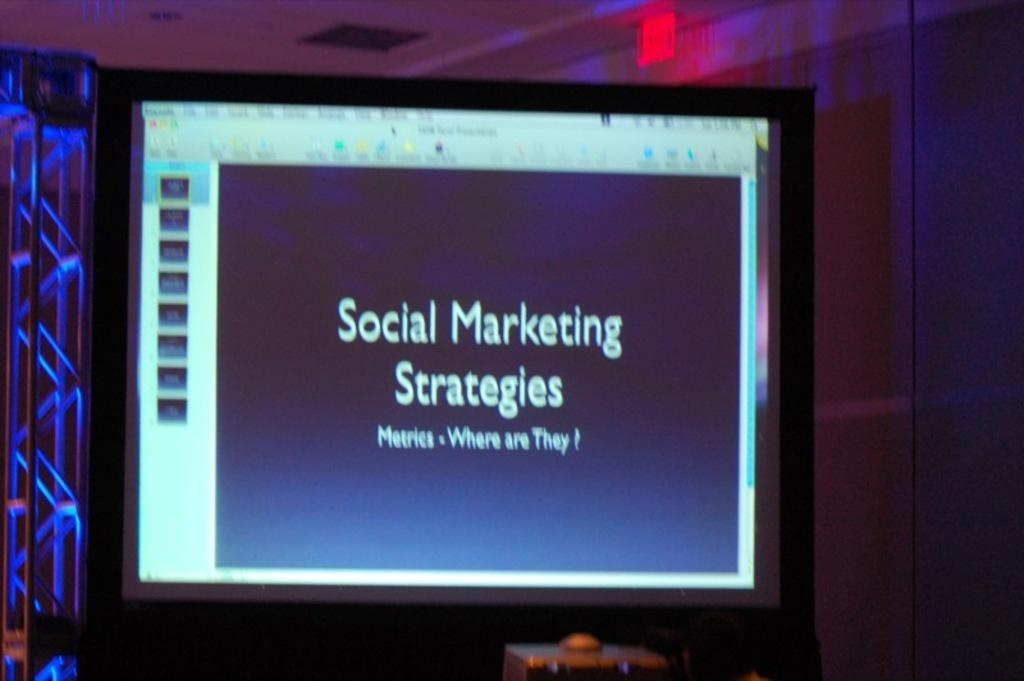<image>
Offer a succinct explanation of the picture presented. the term social marketing strategies is on the screen 